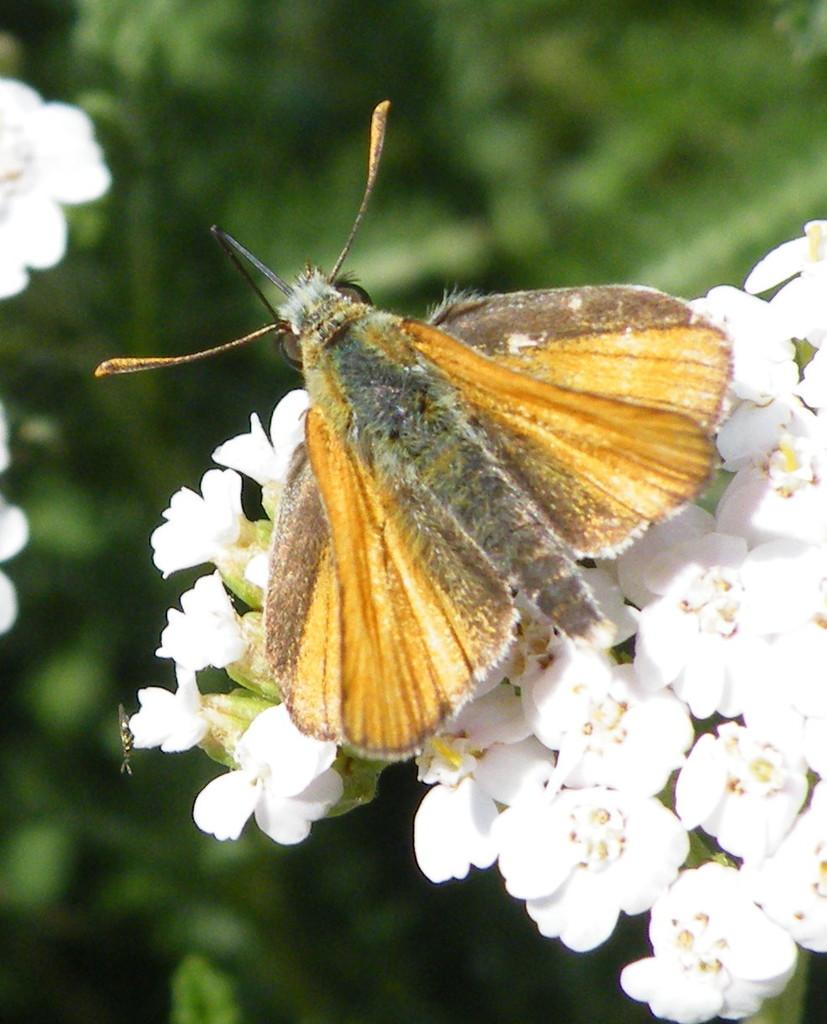What type of insect can be seen in the image? There is a butterfly in the image. What color and type of flowers are on the right side of the image? There are white color flowers on the right side of the image. What can be seen in the background of the image? There are leaves visible in the background of the image. How would you describe the background of the image? The background of the image is blurry. What does the butterfly's mom say about the yoke in the image? There is no mention of a butterfly's mom or a yoke in the image, as the focus is on the butterfly and the surrounding flora. 